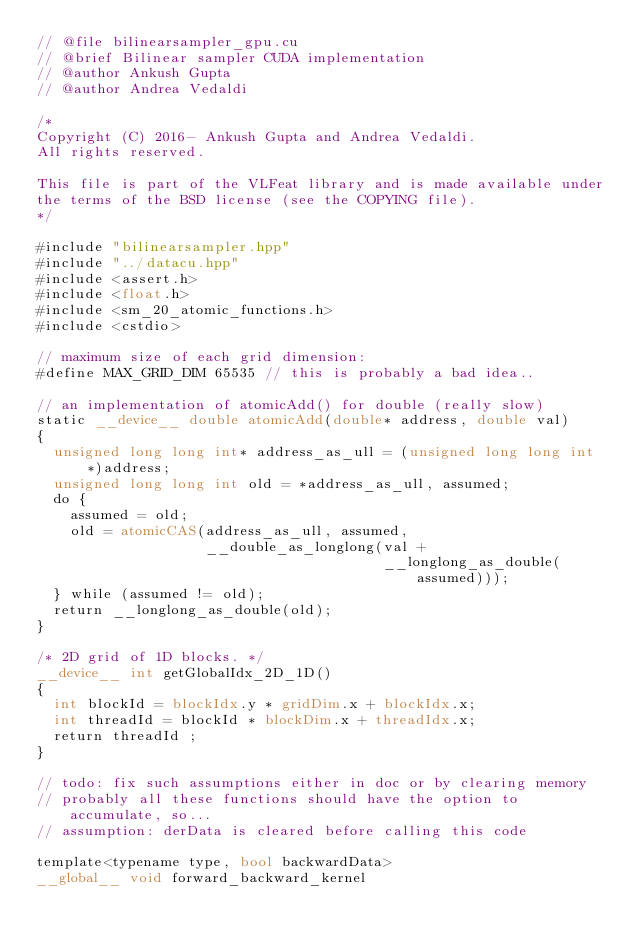<code> <loc_0><loc_0><loc_500><loc_500><_Cuda_>// @file bilinearsampler_gpu.cu
// @brief Bilinear sampler CUDA implementation
// @author Ankush Gupta
// @author Andrea Vedaldi

/*
Copyright (C) 2016- Ankush Gupta and Andrea Vedaldi.
All rights reserved.

This file is part of the VLFeat library and is made available under
the terms of the BSD license (see the COPYING file).
*/

#include "bilinearsampler.hpp"
#include "../datacu.hpp"
#include <assert.h>
#include <float.h>
#include <sm_20_atomic_functions.h>
#include <cstdio>

// maximum size of each grid dimension:
#define MAX_GRID_DIM 65535 // this is probably a bad idea..

// an implementation of atomicAdd() for double (really slow)
static __device__ double atomicAdd(double* address, double val)
{
  unsigned long long int* address_as_ull = (unsigned long long int*)address;
  unsigned long long int old = *address_as_ull, assumed;
  do {
    assumed = old;
    old = atomicCAS(address_as_ull, assumed,
                    __double_as_longlong(val +
                                         __longlong_as_double(assumed)));
  } while (assumed != old);
  return __longlong_as_double(old);
}

/* 2D grid of 1D blocks. */
__device__ int getGlobalIdx_2D_1D()
{
  int blockId = blockIdx.y * gridDim.x + blockIdx.x;
  int threadId = blockId * blockDim.x + threadIdx.x;
  return threadId ;
}

// todo: fix such assumptions either in doc or by clearing memory
// probably all these functions should have the option to accumulate, so...
// assumption: derData is cleared before calling this code

template<typename type, bool backwardData>
__global__ void forward_backward_kernel</code> 